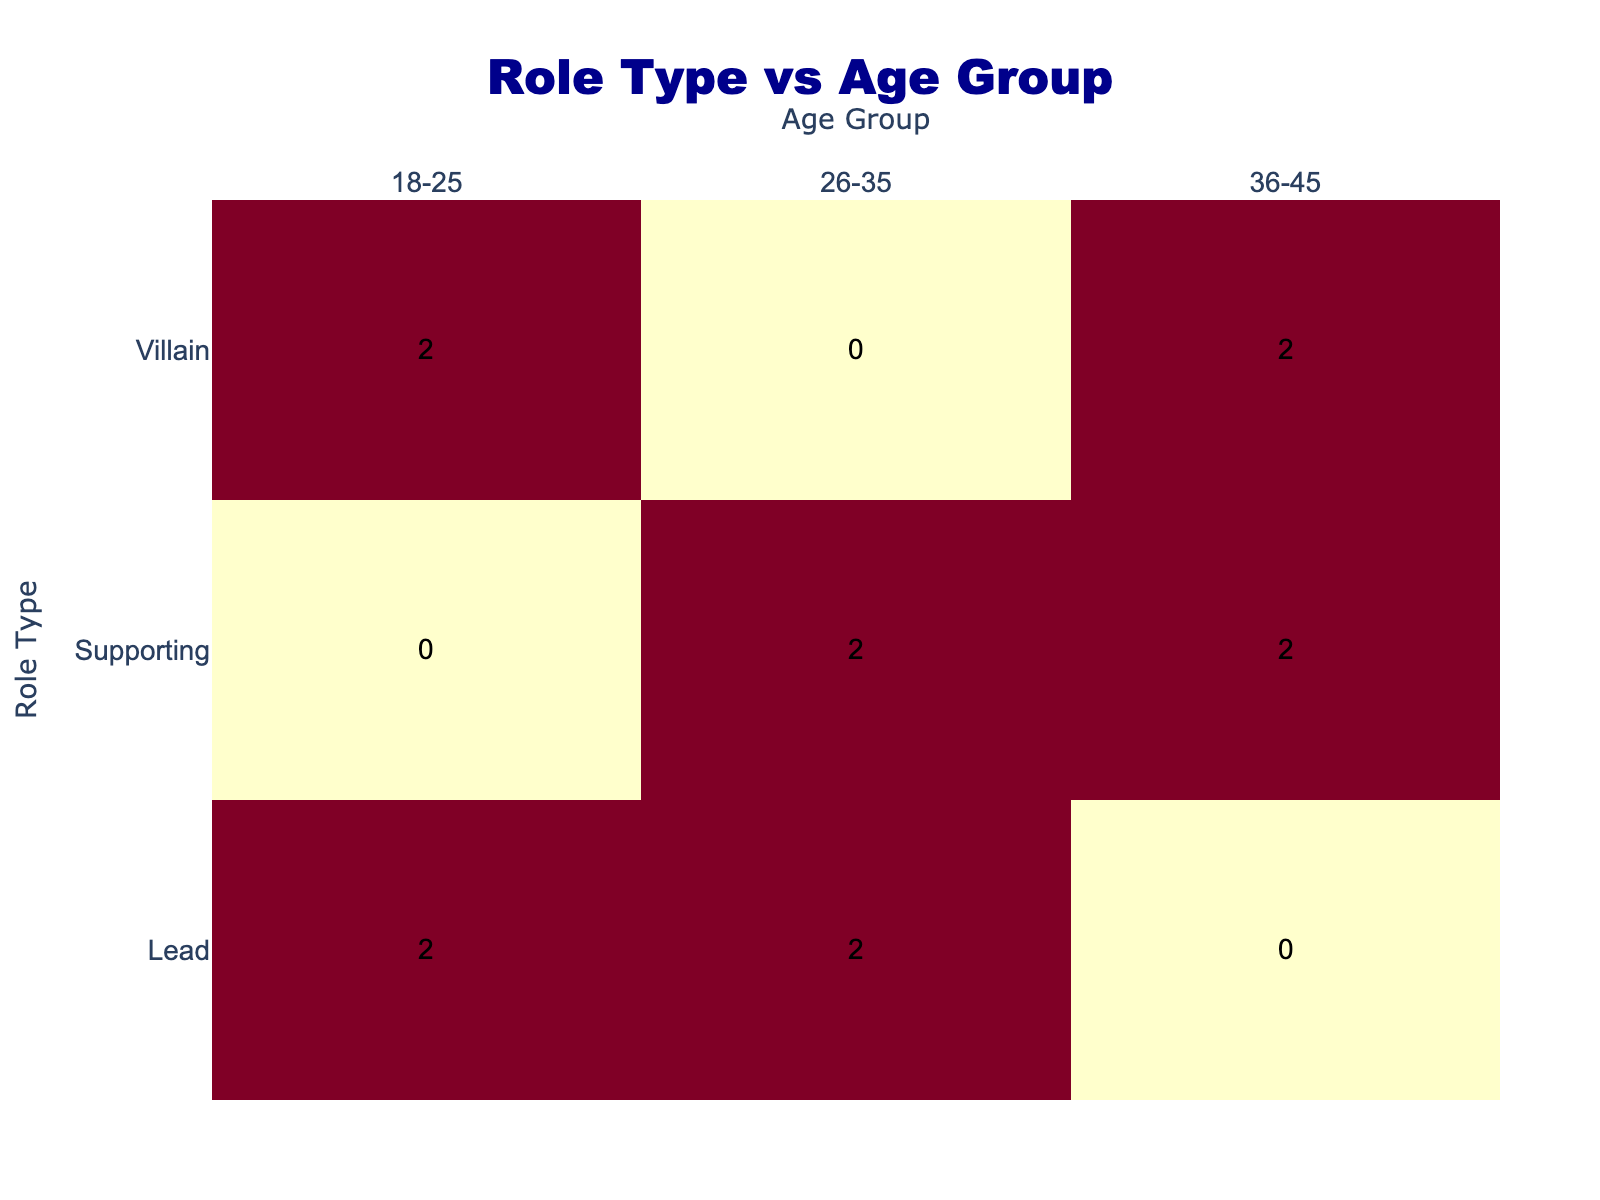What is the total number of actors auditioning for the lead role? The table shows that there are three actors attempting for the lead role: Arjun Das (Success), Priti Mukherjee (Success), and Nitin Saha (Success). Therefore, the total count is 3.
Answer: 3 How many male actors were successful in their auditions? From the table, the successful male actors are Arjun Das (Lead), and Nitin Saha (Lead) while the unsuccessful ones are Mukul Banerjee (Villain), Ravi Chatterjee (Supporting), and Rahul Basu (Villain). Thus, the successful count is 2.
Answer: 2 Is there a female actor in the villain role who was successful? Yes, Ananya Sengupta, who is a female actor in the villain role, was successful in her audition. The presence of this information in the table confirms the fact.
Answer: Yes What percentage of actors in the 26-35 age group were successful? The age group 26-35 has three actors: Sita Roy (Supporting, Success), Ravi Chatterjee (Supporting, Failure), and Tanya Dutta (Lead, Success). Out of these, two were successful: Sita Roy and Tanya Dutta. Thus, the percentage is calculated as (2 successful / 3 total) * 100 = 66.67%.
Answer: 66.67% Which role type has the highest number of auditions from the age group 36-45? The age group 36-45 comprises Mukul Banerjee (Villain, Failure), Ananya Sengupta (Villain, Success), Kamal Ghosh (Supporting, Success), and Riya Banerjee (Supporting, Failure). The Supporting role has the highest count with 2 actors (Kamal Ghosh and Riya Banerjee).
Answer: Supporting How many unique role types are represented in the table? The table shows three unique role types: Lead, Supporting, and Villain. By counting these distinct roles, we confirm there are 3.
Answer: 3 Among the actors aged 18-25, how many are categorized as villains? The age group 18-25 consists of three actors: Arjun Das (Lead, Success), Rahul Basu (Villain, Failure), and Nisha Roy (Villain, Failure). Out of these, two actors (Rahul Basu and Nisha Roy) are categorized as villains.
Answer: 2 What is the total audition outcome count for supporting roles? The supporting role has four actors: Sita Roy (Success), Ravi Chatterjee (Failure), Kamal Ghosh (Success), and Riya Banerjee (Failure). Adding these up results in a total of 4 audition outcomes for supporting roles.
Answer: 4 Did the lead role have a higher success rate than the villain role? To determine this, we see that there were three lead auditions (2 Successful and 1 Failure) and three villain auditions (1 Successful and 2 Failures). The success rate for leads is 66.67% and for villains is 33.33%. Therefore, the lead role has a higher success rate.
Answer: Yes 